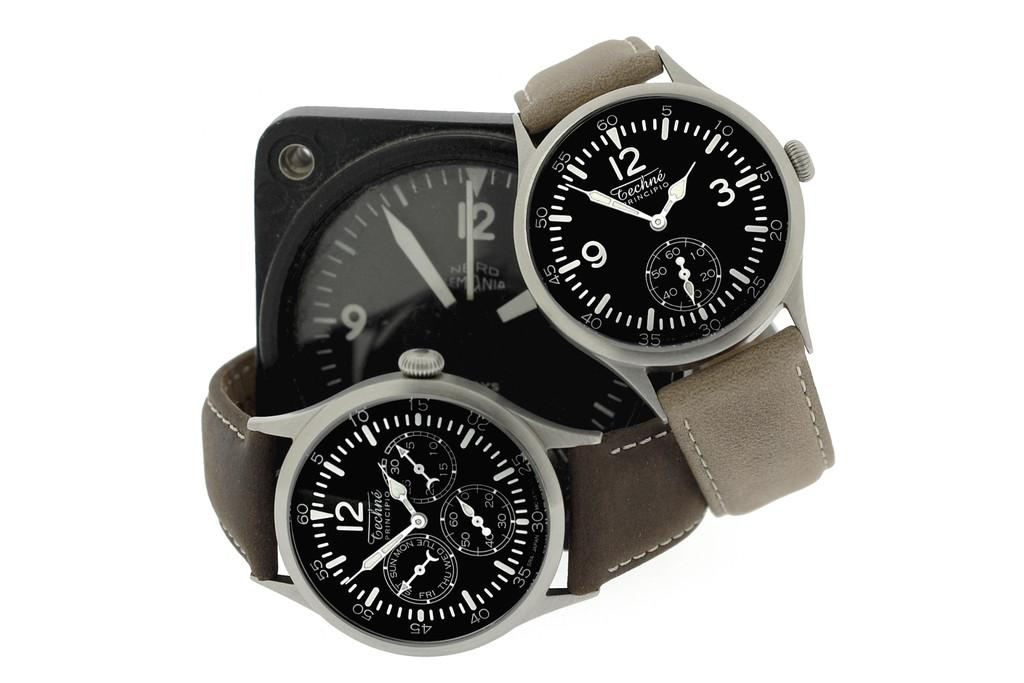<image>
Present a compact description of the photo's key features. Two Technie watches are placed around a desk clock. 